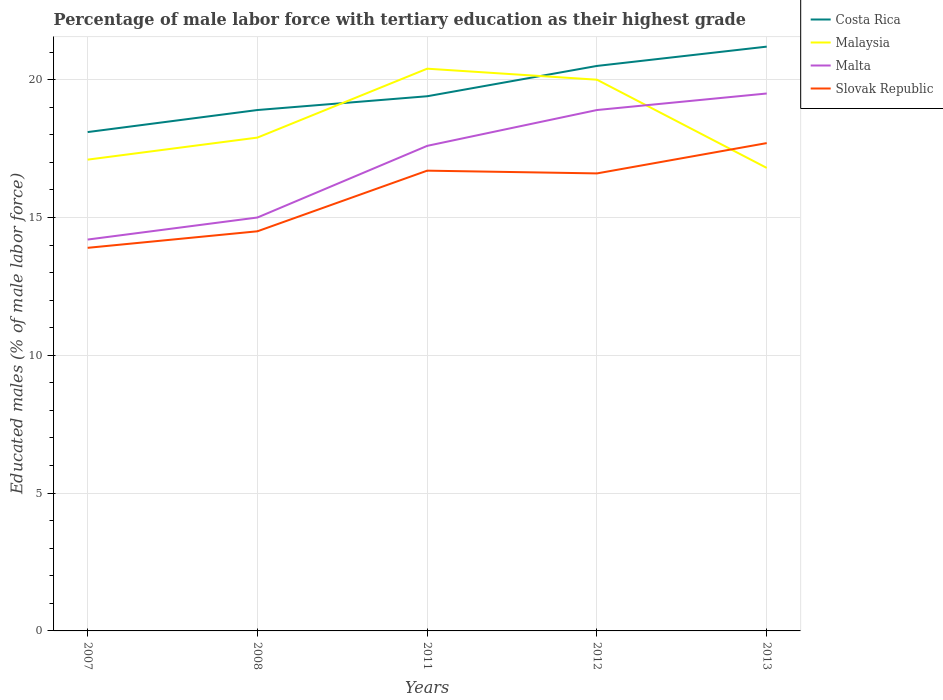Is the number of lines equal to the number of legend labels?
Give a very brief answer. Yes. Across all years, what is the maximum percentage of male labor force with tertiary education in Malaysia?
Your response must be concise. 16.8. In which year was the percentage of male labor force with tertiary education in Costa Rica maximum?
Provide a short and direct response. 2007. What is the total percentage of male labor force with tertiary education in Costa Rica in the graph?
Ensure brevity in your answer.  -0.7. What is the difference between the highest and the second highest percentage of male labor force with tertiary education in Malaysia?
Your answer should be very brief. 3.6. How many lines are there?
Ensure brevity in your answer.  4. Are the values on the major ticks of Y-axis written in scientific E-notation?
Your answer should be compact. No. Does the graph contain any zero values?
Your answer should be very brief. No. How many legend labels are there?
Your answer should be very brief. 4. What is the title of the graph?
Give a very brief answer. Percentage of male labor force with tertiary education as their highest grade. What is the label or title of the X-axis?
Keep it short and to the point. Years. What is the label or title of the Y-axis?
Provide a short and direct response. Educated males (% of male labor force). What is the Educated males (% of male labor force) in Costa Rica in 2007?
Keep it short and to the point. 18.1. What is the Educated males (% of male labor force) of Malaysia in 2007?
Make the answer very short. 17.1. What is the Educated males (% of male labor force) in Malta in 2007?
Your answer should be very brief. 14.2. What is the Educated males (% of male labor force) of Slovak Republic in 2007?
Provide a succinct answer. 13.9. What is the Educated males (% of male labor force) of Costa Rica in 2008?
Make the answer very short. 18.9. What is the Educated males (% of male labor force) in Malaysia in 2008?
Your response must be concise. 17.9. What is the Educated males (% of male labor force) in Costa Rica in 2011?
Provide a succinct answer. 19.4. What is the Educated males (% of male labor force) of Malaysia in 2011?
Provide a succinct answer. 20.4. What is the Educated males (% of male labor force) in Malta in 2011?
Provide a short and direct response. 17.6. What is the Educated males (% of male labor force) in Slovak Republic in 2011?
Your response must be concise. 16.7. What is the Educated males (% of male labor force) in Costa Rica in 2012?
Ensure brevity in your answer.  20.5. What is the Educated males (% of male labor force) in Malaysia in 2012?
Make the answer very short. 20. What is the Educated males (% of male labor force) in Malta in 2012?
Make the answer very short. 18.9. What is the Educated males (% of male labor force) of Slovak Republic in 2012?
Provide a short and direct response. 16.6. What is the Educated males (% of male labor force) of Costa Rica in 2013?
Provide a succinct answer. 21.2. What is the Educated males (% of male labor force) in Malaysia in 2013?
Your answer should be very brief. 16.8. What is the Educated males (% of male labor force) in Malta in 2013?
Offer a very short reply. 19.5. What is the Educated males (% of male labor force) of Slovak Republic in 2013?
Give a very brief answer. 17.7. Across all years, what is the maximum Educated males (% of male labor force) of Costa Rica?
Offer a very short reply. 21.2. Across all years, what is the maximum Educated males (% of male labor force) in Malaysia?
Provide a succinct answer. 20.4. Across all years, what is the maximum Educated males (% of male labor force) in Slovak Republic?
Your answer should be compact. 17.7. Across all years, what is the minimum Educated males (% of male labor force) in Costa Rica?
Ensure brevity in your answer.  18.1. Across all years, what is the minimum Educated males (% of male labor force) of Malaysia?
Offer a very short reply. 16.8. Across all years, what is the minimum Educated males (% of male labor force) of Malta?
Make the answer very short. 14.2. Across all years, what is the minimum Educated males (% of male labor force) in Slovak Republic?
Keep it short and to the point. 13.9. What is the total Educated males (% of male labor force) of Costa Rica in the graph?
Your answer should be very brief. 98.1. What is the total Educated males (% of male labor force) of Malaysia in the graph?
Provide a short and direct response. 92.2. What is the total Educated males (% of male labor force) of Malta in the graph?
Your answer should be compact. 85.2. What is the total Educated males (% of male labor force) in Slovak Republic in the graph?
Keep it short and to the point. 79.4. What is the difference between the Educated males (% of male labor force) in Costa Rica in 2007 and that in 2008?
Provide a short and direct response. -0.8. What is the difference between the Educated males (% of male labor force) in Malaysia in 2007 and that in 2008?
Make the answer very short. -0.8. What is the difference between the Educated males (% of male labor force) in Slovak Republic in 2007 and that in 2008?
Offer a terse response. -0.6. What is the difference between the Educated males (% of male labor force) in Slovak Republic in 2007 and that in 2011?
Your answer should be compact. -2.8. What is the difference between the Educated males (% of male labor force) in Costa Rica in 2007 and that in 2012?
Provide a succinct answer. -2.4. What is the difference between the Educated males (% of male labor force) of Malta in 2007 and that in 2012?
Your answer should be compact. -4.7. What is the difference between the Educated males (% of male labor force) in Costa Rica in 2007 and that in 2013?
Your answer should be compact. -3.1. What is the difference between the Educated males (% of male labor force) in Malaysia in 2007 and that in 2013?
Ensure brevity in your answer.  0.3. What is the difference between the Educated males (% of male labor force) of Malta in 2007 and that in 2013?
Provide a succinct answer. -5.3. What is the difference between the Educated males (% of male labor force) in Slovak Republic in 2007 and that in 2013?
Your answer should be very brief. -3.8. What is the difference between the Educated males (% of male labor force) of Slovak Republic in 2008 and that in 2011?
Make the answer very short. -2.2. What is the difference between the Educated males (% of male labor force) in Costa Rica in 2008 and that in 2012?
Provide a succinct answer. -1.6. What is the difference between the Educated males (% of male labor force) of Malaysia in 2008 and that in 2012?
Your answer should be compact. -2.1. What is the difference between the Educated males (% of male labor force) of Slovak Republic in 2008 and that in 2012?
Offer a very short reply. -2.1. What is the difference between the Educated males (% of male labor force) in Malaysia in 2008 and that in 2013?
Offer a very short reply. 1.1. What is the difference between the Educated males (% of male labor force) of Malaysia in 2011 and that in 2013?
Ensure brevity in your answer.  3.6. What is the difference between the Educated males (% of male labor force) of Slovak Republic in 2011 and that in 2013?
Make the answer very short. -1. What is the difference between the Educated males (% of male labor force) in Costa Rica in 2012 and that in 2013?
Provide a short and direct response. -0.7. What is the difference between the Educated males (% of male labor force) of Malaysia in 2012 and that in 2013?
Ensure brevity in your answer.  3.2. What is the difference between the Educated males (% of male labor force) of Slovak Republic in 2012 and that in 2013?
Your answer should be compact. -1.1. What is the difference between the Educated males (% of male labor force) of Costa Rica in 2007 and the Educated males (% of male labor force) of Malaysia in 2008?
Give a very brief answer. 0.2. What is the difference between the Educated males (% of male labor force) in Costa Rica in 2007 and the Educated males (% of male labor force) in Malta in 2008?
Make the answer very short. 3.1. What is the difference between the Educated males (% of male labor force) in Costa Rica in 2007 and the Educated males (% of male labor force) in Malta in 2011?
Keep it short and to the point. 0.5. What is the difference between the Educated males (% of male labor force) in Malta in 2007 and the Educated males (% of male labor force) in Slovak Republic in 2011?
Provide a short and direct response. -2.5. What is the difference between the Educated males (% of male labor force) in Costa Rica in 2007 and the Educated males (% of male labor force) in Malaysia in 2012?
Make the answer very short. -1.9. What is the difference between the Educated males (% of male labor force) in Costa Rica in 2007 and the Educated males (% of male labor force) in Malta in 2012?
Make the answer very short. -0.8. What is the difference between the Educated males (% of male labor force) of Malta in 2007 and the Educated males (% of male labor force) of Slovak Republic in 2012?
Provide a succinct answer. -2.4. What is the difference between the Educated males (% of male labor force) in Costa Rica in 2007 and the Educated males (% of male labor force) in Malaysia in 2013?
Offer a very short reply. 1.3. What is the difference between the Educated males (% of male labor force) of Malaysia in 2007 and the Educated males (% of male labor force) of Malta in 2013?
Your response must be concise. -2.4. What is the difference between the Educated males (% of male labor force) in Malta in 2007 and the Educated males (% of male labor force) in Slovak Republic in 2013?
Your answer should be compact. -3.5. What is the difference between the Educated males (% of male labor force) in Costa Rica in 2008 and the Educated males (% of male labor force) in Malaysia in 2011?
Offer a very short reply. -1.5. What is the difference between the Educated males (% of male labor force) of Costa Rica in 2008 and the Educated males (% of male labor force) of Malta in 2011?
Your answer should be very brief. 1.3. What is the difference between the Educated males (% of male labor force) in Costa Rica in 2008 and the Educated males (% of male labor force) in Slovak Republic in 2011?
Make the answer very short. 2.2. What is the difference between the Educated males (% of male labor force) in Malaysia in 2008 and the Educated males (% of male labor force) in Slovak Republic in 2011?
Keep it short and to the point. 1.2. What is the difference between the Educated males (% of male labor force) in Costa Rica in 2008 and the Educated males (% of male labor force) in Malta in 2012?
Make the answer very short. 0. What is the difference between the Educated males (% of male labor force) in Costa Rica in 2008 and the Educated males (% of male labor force) in Slovak Republic in 2012?
Make the answer very short. 2.3. What is the difference between the Educated males (% of male labor force) in Costa Rica in 2008 and the Educated males (% of male labor force) in Malaysia in 2013?
Ensure brevity in your answer.  2.1. What is the difference between the Educated males (% of male labor force) of Costa Rica in 2008 and the Educated males (% of male labor force) of Slovak Republic in 2013?
Offer a very short reply. 1.2. What is the difference between the Educated males (% of male labor force) in Costa Rica in 2011 and the Educated males (% of male labor force) in Slovak Republic in 2012?
Provide a short and direct response. 2.8. What is the difference between the Educated males (% of male labor force) in Malaysia in 2011 and the Educated males (% of male labor force) in Slovak Republic in 2012?
Provide a short and direct response. 3.8. What is the difference between the Educated males (% of male labor force) in Malta in 2011 and the Educated males (% of male labor force) in Slovak Republic in 2012?
Offer a terse response. 1. What is the difference between the Educated males (% of male labor force) in Costa Rica in 2011 and the Educated males (% of male labor force) in Malta in 2013?
Your response must be concise. -0.1. What is the difference between the Educated males (% of male labor force) of Malaysia in 2011 and the Educated males (% of male labor force) of Slovak Republic in 2013?
Provide a succinct answer. 2.7. What is the difference between the Educated males (% of male labor force) in Malta in 2011 and the Educated males (% of male labor force) in Slovak Republic in 2013?
Your answer should be compact. -0.1. What is the difference between the Educated males (% of male labor force) of Malaysia in 2012 and the Educated males (% of male labor force) of Slovak Republic in 2013?
Ensure brevity in your answer.  2.3. What is the difference between the Educated males (% of male labor force) of Malta in 2012 and the Educated males (% of male labor force) of Slovak Republic in 2013?
Give a very brief answer. 1.2. What is the average Educated males (% of male labor force) of Costa Rica per year?
Your answer should be very brief. 19.62. What is the average Educated males (% of male labor force) of Malaysia per year?
Offer a very short reply. 18.44. What is the average Educated males (% of male labor force) of Malta per year?
Offer a terse response. 17.04. What is the average Educated males (% of male labor force) in Slovak Republic per year?
Your answer should be very brief. 15.88. In the year 2007, what is the difference between the Educated males (% of male labor force) of Costa Rica and Educated males (% of male labor force) of Malaysia?
Your answer should be very brief. 1. In the year 2007, what is the difference between the Educated males (% of male labor force) in Costa Rica and Educated males (% of male labor force) in Malta?
Make the answer very short. 3.9. In the year 2007, what is the difference between the Educated males (% of male labor force) of Malaysia and Educated males (% of male labor force) of Slovak Republic?
Provide a short and direct response. 3.2. In the year 2008, what is the difference between the Educated males (% of male labor force) in Costa Rica and Educated males (% of male labor force) in Malaysia?
Your response must be concise. 1. In the year 2011, what is the difference between the Educated males (% of male labor force) of Costa Rica and Educated males (% of male labor force) of Malaysia?
Keep it short and to the point. -1. In the year 2011, what is the difference between the Educated males (% of male labor force) in Costa Rica and Educated males (% of male labor force) in Malta?
Offer a very short reply. 1.8. In the year 2011, what is the difference between the Educated males (% of male labor force) of Costa Rica and Educated males (% of male labor force) of Slovak Republic?
Your answer should be compact. 2.7. In the year 2011, what is the difference between the Educated males (% of male labor force) of Malta and Educated males (% of male labor force) of Slovak Republic?
Offer a very short reply. 0.9. In the year 2012, what is the difference between the Educated males (% of male labor force) in Costa Rica and Educated males (% of male labor force) in Malaysia?
Offer a terse response. 0.5. In the year 2012, what is the difference between the Educated males (% of male labor force) of Malaysia and Educated males (% of male labor force) of Slovak Republic?
Offer a very short reply. 3.4. In the year 2013, what is the difference between the Educated males (% of male labor force) of Costa Rica and Educated males (% of male labor force) of Malta?
Your answer should be very brief. 1.7. In the year 2013, what is the difference between the Educated males (% of male labor force) of Costa Rica and Educated males (% of male labor force) of Slovak Republic?
Make the answer very short. 3.5. In the year 2013, what is the difference between the Educated males (% of male labor force) in Malta and Educated males (% of male labor force) in Slovak Republic?
Keep it short and to the point. 1.8. What is the ratio of the Educated males (% of male labor force) of Costa Rica in 2007 to that in 2008?
Your response must be concise. 0.96. What is the ratio of the Educated males (% of male labor force) of Malaysia in 2007 to that in 2008?
Provide a succinct answer. 0.96. What is the ratio of the Educated males (% of male labor force) in Malta in 2007 to that in 2008?
Give a very brief answer. 0.95. What is the ratio of the Educated males (% of male labor force) of Slovak Republic in 2007 to that in 2008?
Provide a short and direct response. 0.96. What is the ratio of the Educated males (% of male labor force) of Costa Rica in 2007 to that in 2011?
Your answer should be compact. 0.93. What is the ratio of the Educated males (% of male labor force) of Malaysia in 2007 to that in 2011?
Provide a succinct answer. 0.84. What is the ratio of the Educated males (% of male labor force) in Malta in 2007 to that in 2011?
Your answer should be compact. 0.81. What is the ratio of the Educated males (% of male labor force) of Slovak Republic in 2007 to that in 2011?
Provide a succinct answer. 0.83. What is the ratio of the Educated males (% of male labor force) of Costa Rica in 2007 to that in 2012?
Ensure brevity in your answer.  0.88. What is the ratio of the Educated males (% of male labor force) of Malaysia in 2007 to that in 2012?
Ensure brevity in your answer.  0.85. What is the ratio of the Educated males (% of male labor force) of Malta in 2007 to that in 2012?
Your answer should be very brief. 0.75. What is the ratio of the Educated males (% of male labor force) of Slovak Republic in 2007 to that in 2012?
Your answer should be very brief. 0.84. What is the ratio of the Educated males (% of male labor force) of Costa Rica in 2007 to that in 2013?
Offer a very short reply. 0.85. What is the ratio of the Educated males (% of male labor force) of Malaysia in 2007 to that in 2013?
Offer a very short reply. 1.02. What is the ratio of the Educated males (% of male labor force) in Malta in 2007 to that in 2013?
Your response must be concise. 0.73. What is the ratio of the Educated males (% of male labor force) in Slovak Republic in 2007 to that in 2013?
Give a very brief answer. 0.79. What is the ratio of the Educated males (% of male labor force) of Costa Rica in 2008 to that in 2011?
Provide a succinct answer. 0.97. What is the ratio of the Educated males (% of male labor force) in Malaysia in 2008 to that in 2011?
Give a very brief answer. 0.88. What is the ratio of the Educated males (% of male labor force) in Malta in 2008 to that in 2011?
Your answer should be compact. 0.85. What is the ratio of the Educated males (% of male labor force) in Slovak Republic in 2008 to that in 2011?
Your answer should be very brief. 0.87. What is the ratio of the Educated males (% of male labor force) of Costa Rica in 2008 to that in 2012?
Ensure brevity in your answer.  0.92. What is the ratio of the Educated males (% of male labor force) of Malaysia in 2008 to that in 2012?
Give a very brief answer. 0.9. What is the ratio of the Educated males (% of male labor force) in Malta in 2008 to that in 2012?
Ensure brevity in your answer.  0.79. What is the ratio of the Educated males (% of male labor force) of Slovak Republic in 2008 to that in 2012?
Provide a succinct answer. 0.87. What is the ratio of the Educated males (% of male labor force) in Costa Rica in 2008 to that in 2013?
Offer a very short reply. 0.89. What is the ratio of the Educated males (% of male labor force) of Malaysia in 2008 to that in 2013?
Your answer should be compact. 1.07. What is the ratio of the Educated males (% of male labor force) of Malta in 2008 to that in 2013?
Keep it short and to the point. 0.77. What is the ratio of the Educated males (% of male labor force) of Slovak Republic in 2008 to that in 2013?
Give a very brief answer. 0.82. What is the ratio of the Educated males (% of male labor force) of Costa Rica in 2011 to that in 2012?
Provide a short and direct response. 0.95. What is the ratio of the Educated males (% of male labor force) in Malaysia in 2011 to that in 2012?
Keep it short and to the point. 1.02. What is the ratio of the Educated males (% of male labor force) in Malta in 2011 to that in 2012?
Offer a terse response. 0.93. What is the ratio of the Educated males (% of male labor force) of Costa Rica in 2011 to that in 2013?
Your answer should be very brief. 0.92. What is the ratio of the Educated males (% of male labor force) in Malaysia in 2011 to that in 2013?
Keep it short and to the point. 1.21. What is the ratio of the Educated males (% of male labor force) of Malta in 2011 to that in 2013?
Offer a terse response. 0.9. What is the ratio of the Educated males (% of male labor force) of Slovak Republic in 2011 to that in 2013?
Ensure brevity in your answer.  0.94. What is the ratio of the Educated males (% of male labor force) of Costa Rica in 2012 to that in 2013?
Offer a very short reply. 0.97. What is the ratio of the Educated males (% of male labor force) of Malaysia in 2012 to that in 2013?
Your answer should be very brief. 1.19. What is the ratio of the Educated males (% of male labor force) of Malta in 2012 to that in 2013?
Ensure brevity in your answer.  0.97. What is the ratio of the Educated males (% of male labor force) of Slovak Republic in 2012 to that in 2013?
Ensure brevity in your answer.  0.94. What is the difference between the highest and the second highest Educated males (% of male labor force) of Costa Rica?
Provide a succinct answer. 0.7. What is the difference between the highest and the second highest Educated males (% of male labor force) of Malaysia?
Offer a terse response. 0.4. What is the difference between the highest and the second highest Educated males (% of male labor force) in Malta?
Provide a succinct answer. 0.6. What is the difference between the highest and the lowest Educated males (% of male labor force) of Costa Rica?
Provide a succinct answer. 3.1. 